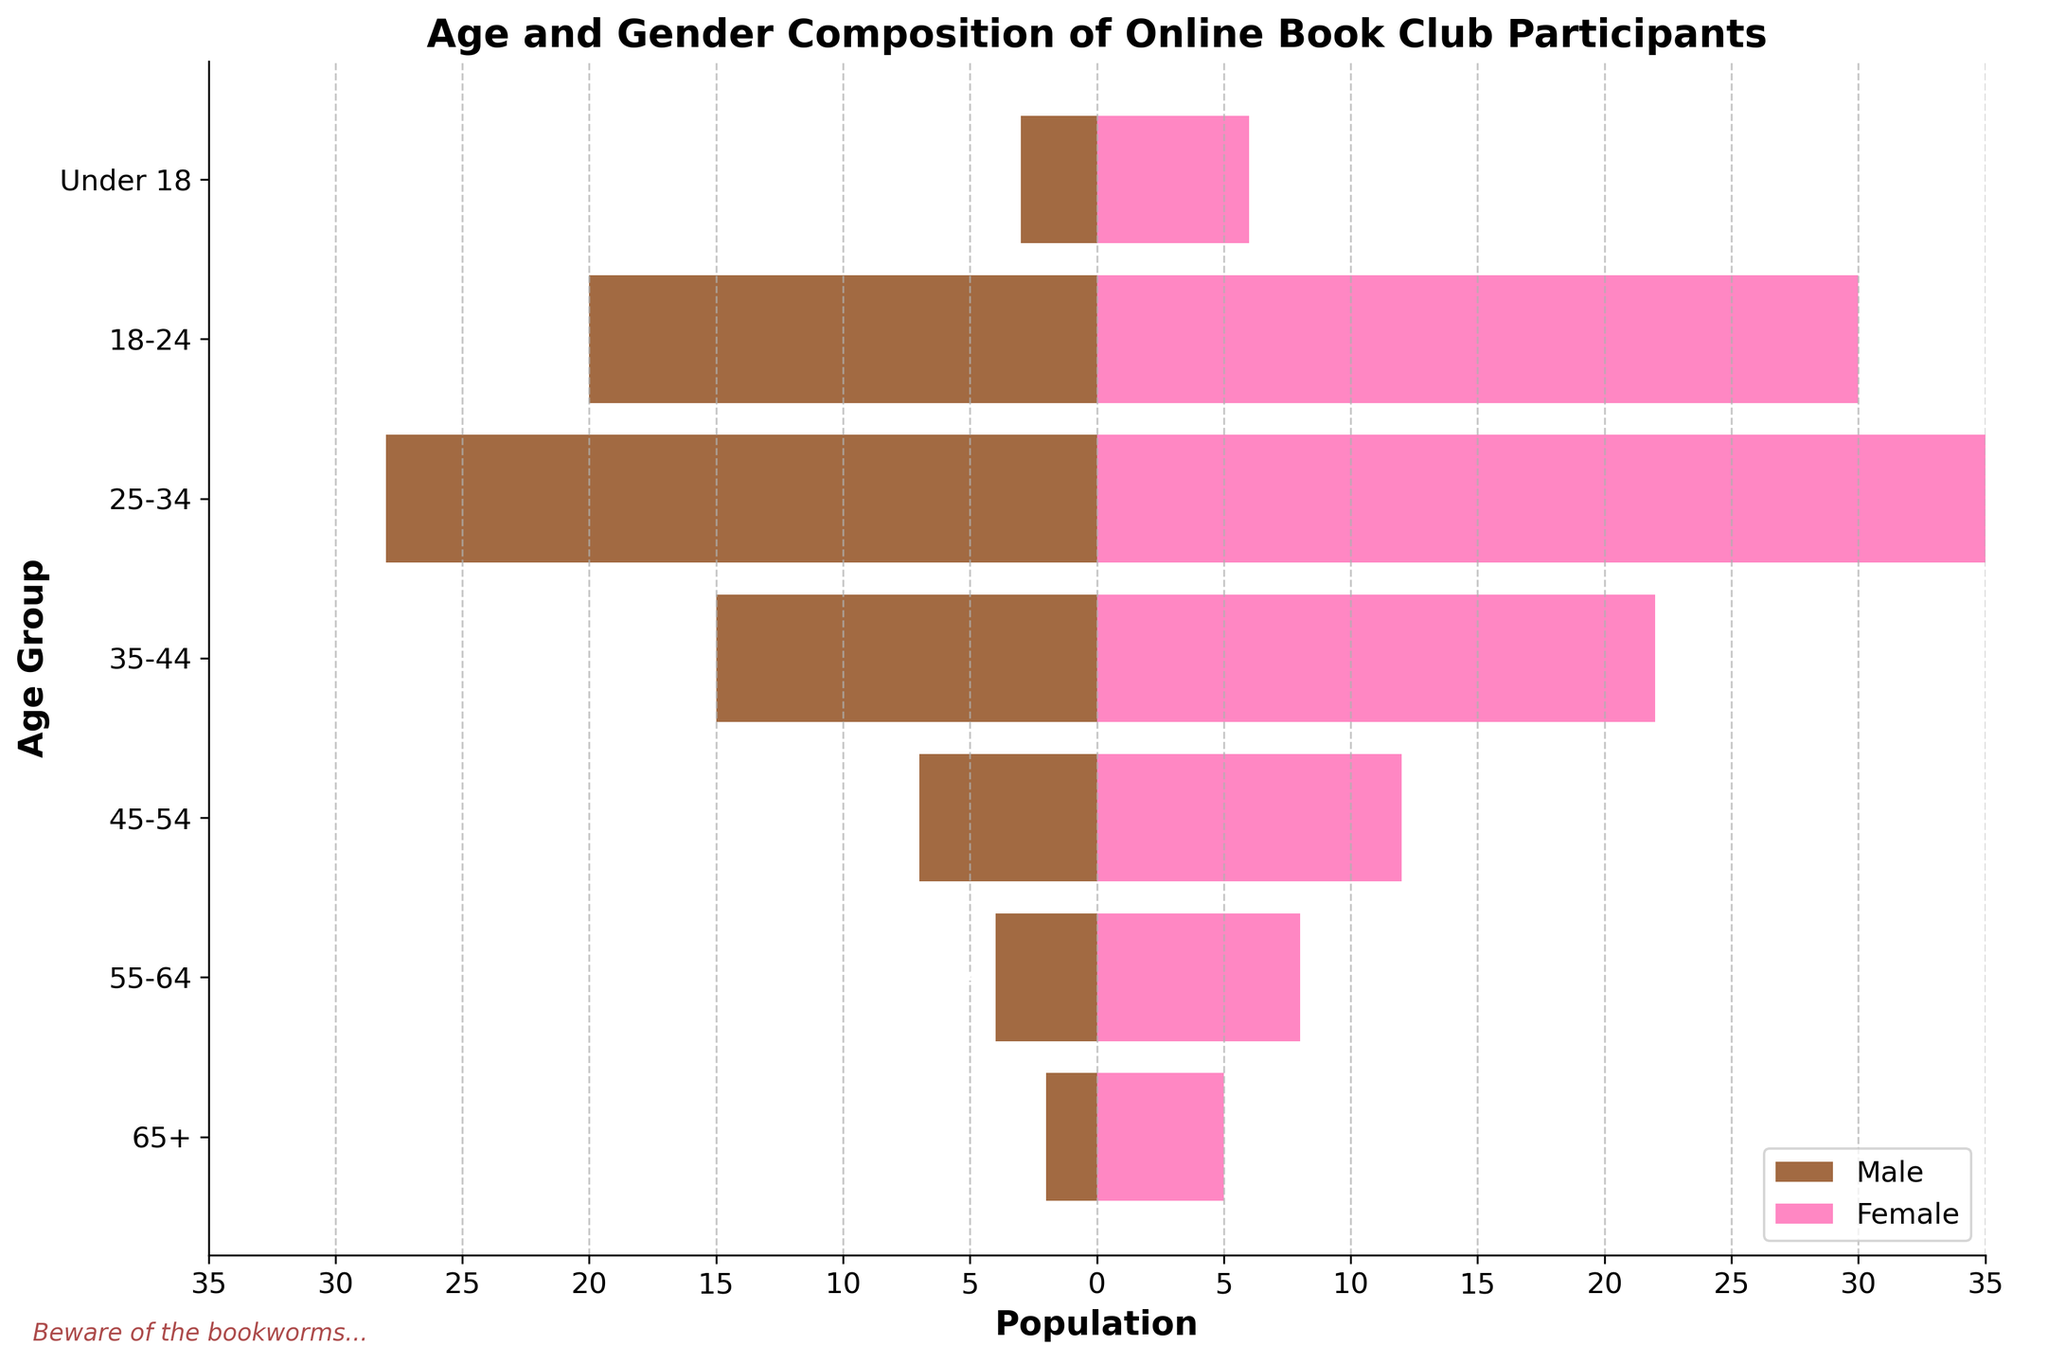What is the title of the figure? The title is usually displayed at the top of the figure, and it summarizes the subject of the plot. In this case, it’s visible at the top of the population pyramid.
Answer: Age and Gender Composition of Online Book Club Participants Which age group has the highest number of female participants? To answer this, we need to look for the age group with the longest pink bar. The 25-34 age group has the longest bar on the female side.
Answer: 25-34 Which age group has the minimal number of male participants? We need to look for the age group with the shortest brown bar on the male side. The shortest brown bar is for the 65+ age group.
Answer: 65+ How many total participants are there in the 45-54 age group? We calculate the total by summing the male and female participants in the 45-54 age group. There are 7 males and 12 females.
Answer: 19 In which age group is the gender gap largest? The gender gap can be calculated by finding the absolute difference between the number of males and females in each age group. Checking each difference: 65+ (3), 55-64 (4), 45-54 (5), 35-44 (7), 25-34 (7), 18-24 (10), Under 18 (3). The largest gap is in the 18-24 age group.
Answer: 18-24 What is the total number of male participants across all age groups? Summing the male participants across all age groups: 2 + 4 + 7 + 15 + 28 + 20 + 3.
Answer: 79 Do more under-18 males or 65+ females participate in the book club? Comparing the number of participants in the "Under 18" male category to the "65+" female category. There are 3 males under 18 and 5 females in the 65+ category.
Answer: 65+ females What is the proportion of participants in the 25-34 age group relative to the total number of participants? First, find the total number of participants in the 25-34 age group (28 males and 35 females equals 63). Then, sum the total number of participants across all age groups (2+4+7+15+28+20+3 males + 5+8+12+22+35+30+6 females). Lastly, divide the number of participants in the 25-34 age group by the total number of participants. Total participants are 226. Proportion = 63/226.
Answer: Approximately 0.279 or 27.9% Which age group has a higher number of males than females? We need to check each age group where the male bar (brown) extends further left than the female bar extends right. All age groups have more females than males.
Answer: None Are there more males or females in the age group 18-24? Compare the length of the bar representing males (brown) with that representing females (pink) in the 18-24 age group. There are 20 males and 30 females, meaning more females.
Answer: Females 